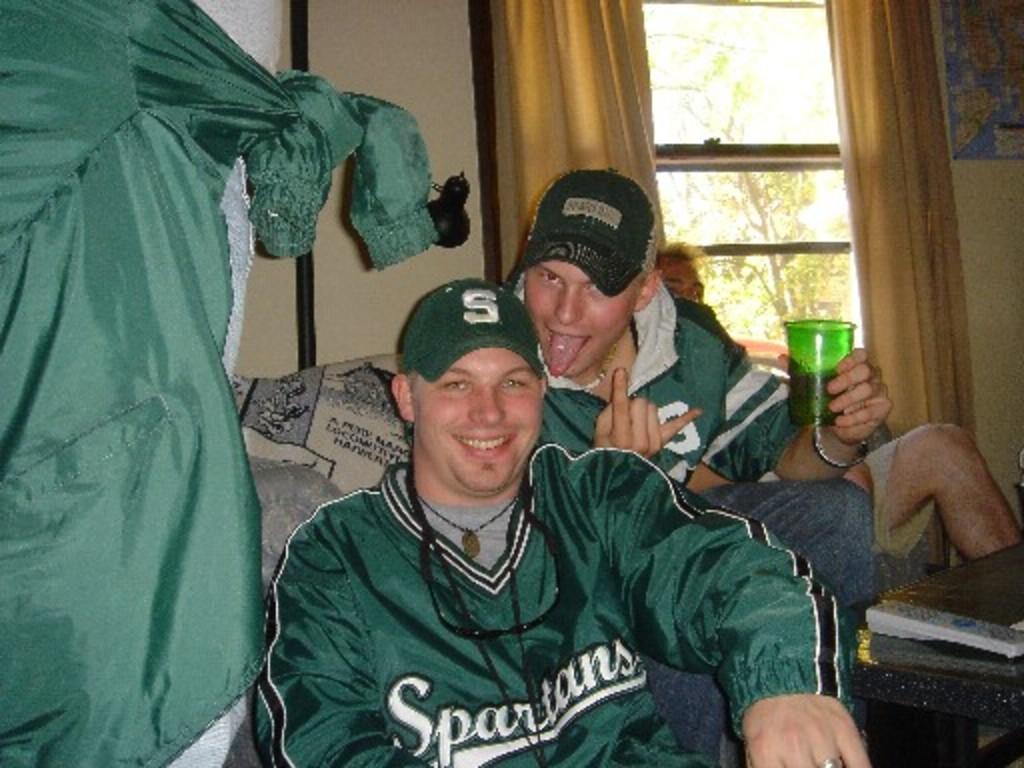What letter is on the green hat in the middle?
Provide a succinct answer. S. 